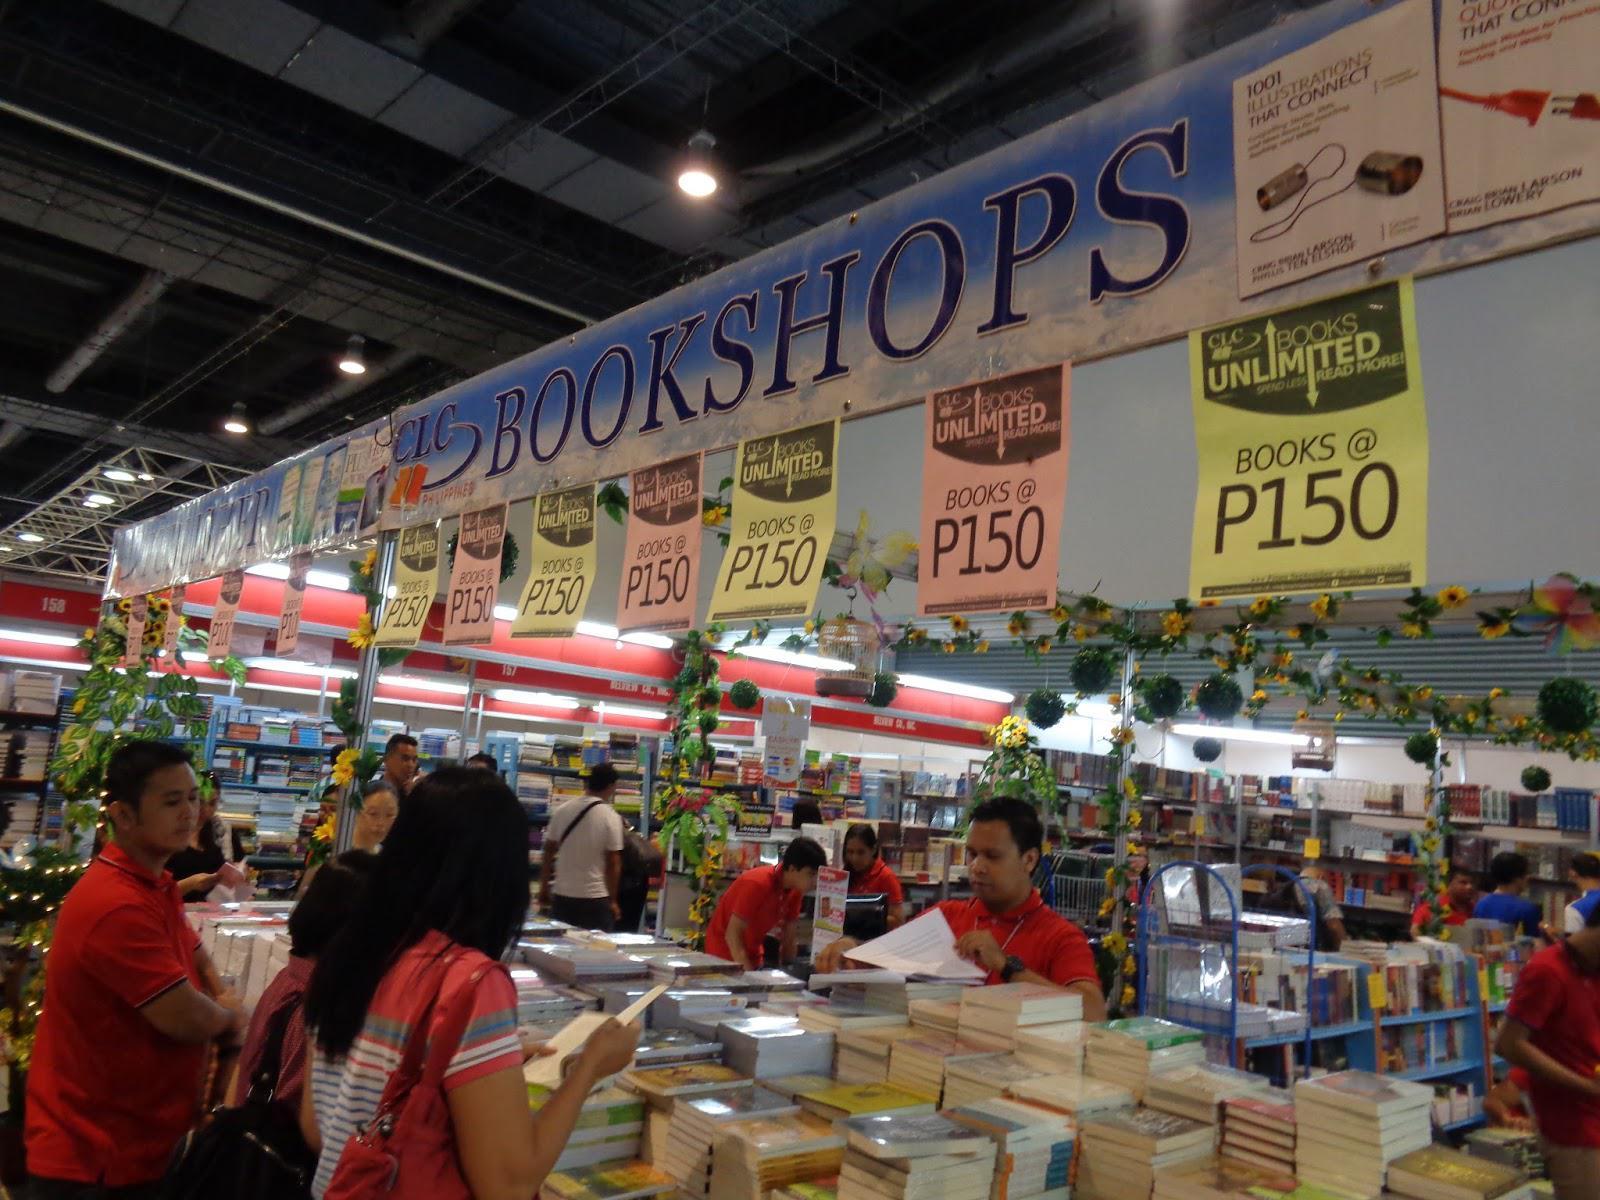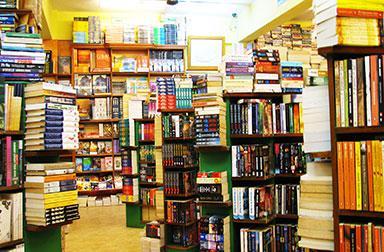The first image is the image on the left, the second image is the image on the right. Assess this claim about the two images: "In one of the images there are at least three people shopping in a bookstore.". Correct or not? Answer yes or no. Yes. The first image is the image on the left, the second image is the image on the right. Examine the images to the left and right. Is the description "Left image includes multiple media items with anime characters on the cover and a display featuring bright red and blonde wood." accurate? Answer yes or no. No. 